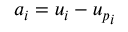Convert formula to latex. <formula><loc_0><loc_0><loc_500><loc_500>a _ { i } = u _ { i } - { u _ { p } } _ { i }</formula> 